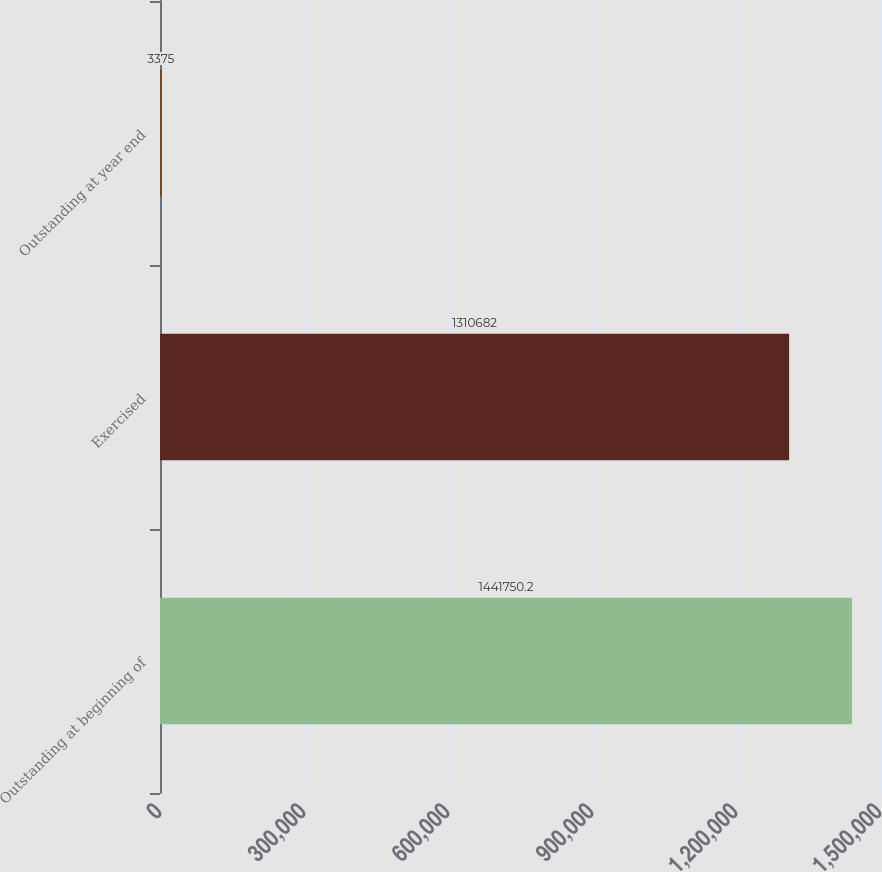Convert chart. <chart><loc_0><loc_0><loc_500><loc_500><bar_chart><fcel>Outstanding at beginning of<fcel>Exercised<fcel>Outstanding at year end<nl><fcel>1.44175e+06<fcel>1.31068e+06<fcel>3375<nl></chart> 